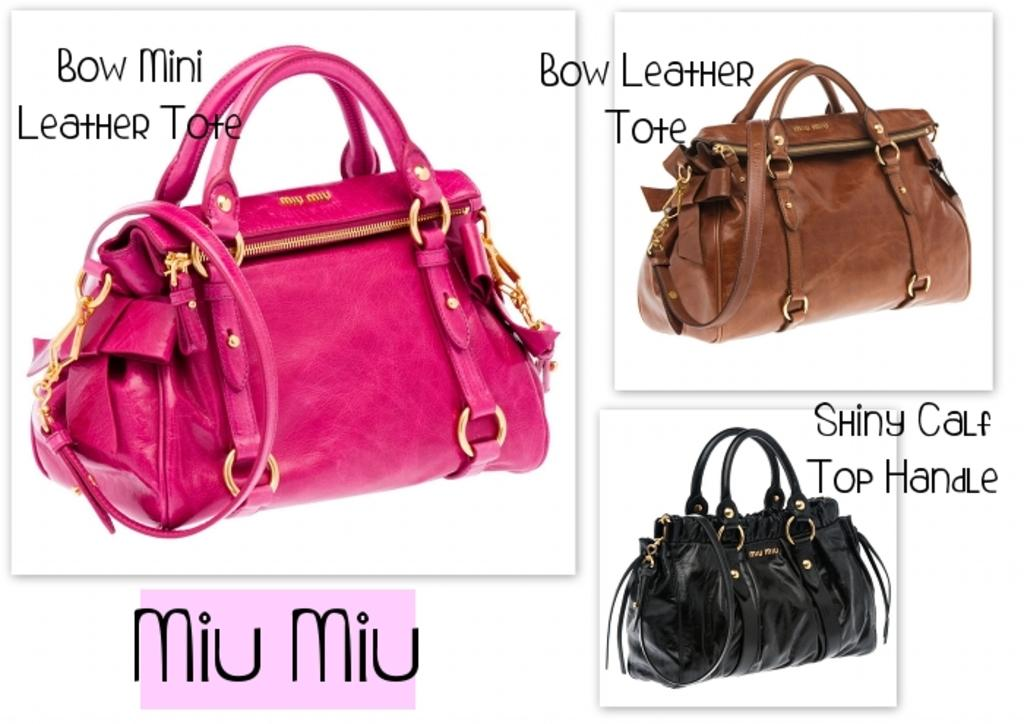How many handbags are visible in the image? There are three colorful handbags in the image. Can you describe the appearance of the handbags? The handbags are colorful, but no specific colors are mentioned in the facts. Has the image been altered in any way? Yes, the image has been edited. Is there a spoon visible in the image? No, there is no spoon present in the image. Is the image taken during a snowy day? The facts do not mention any snow or weather conditions, so it cannot be determined from the image. 